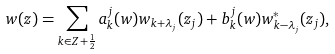Convert formula to latex. <formula><loc_0><loc_0><loc_500><loc_500>w ( z ) = \sum _ { k \in { Z } + \frac { 1 } { 2 } } a _ { k } ^ { j } ( w ) w _ { k + \lambda _ { j } } ( z _ { j } ) + b _ { k } ^ { j } ( w ) w ^ { * } _ { k - \lambda _ { j } } ( z _ { j } ) ,</formula> 